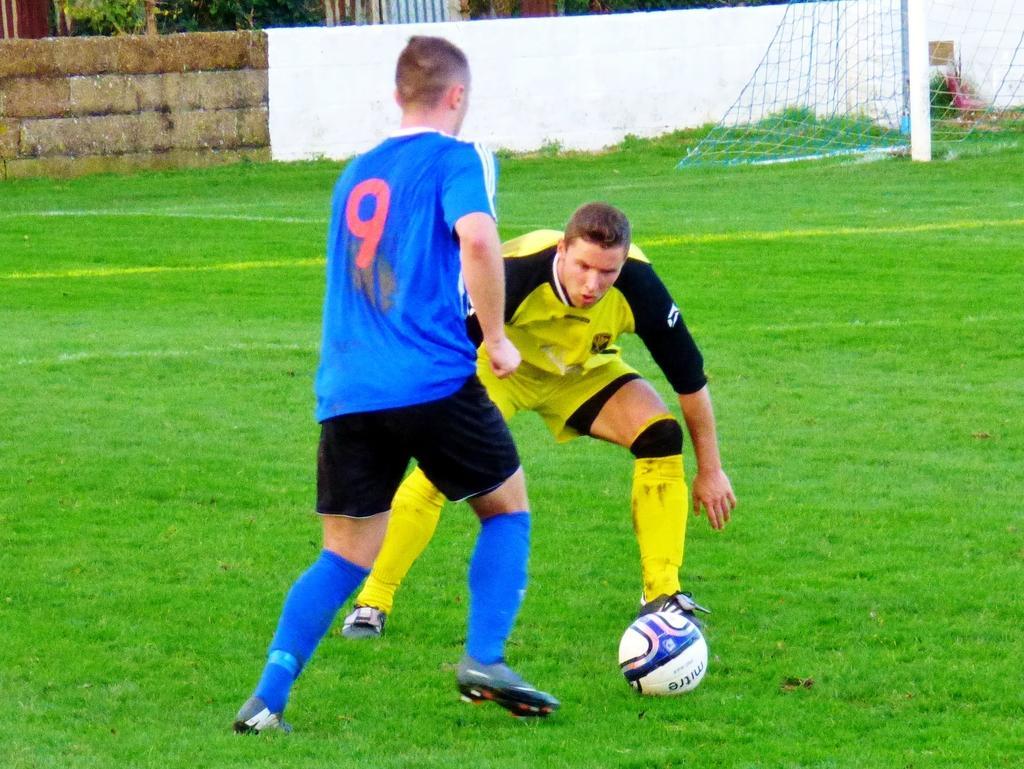In one or two sentences, can you explain what this image depicts? In this image, we can see some people wearing T-shirt and shorts. We can see the ground with some grass. We can see a ball and the net. We can see the wall and some plants. 